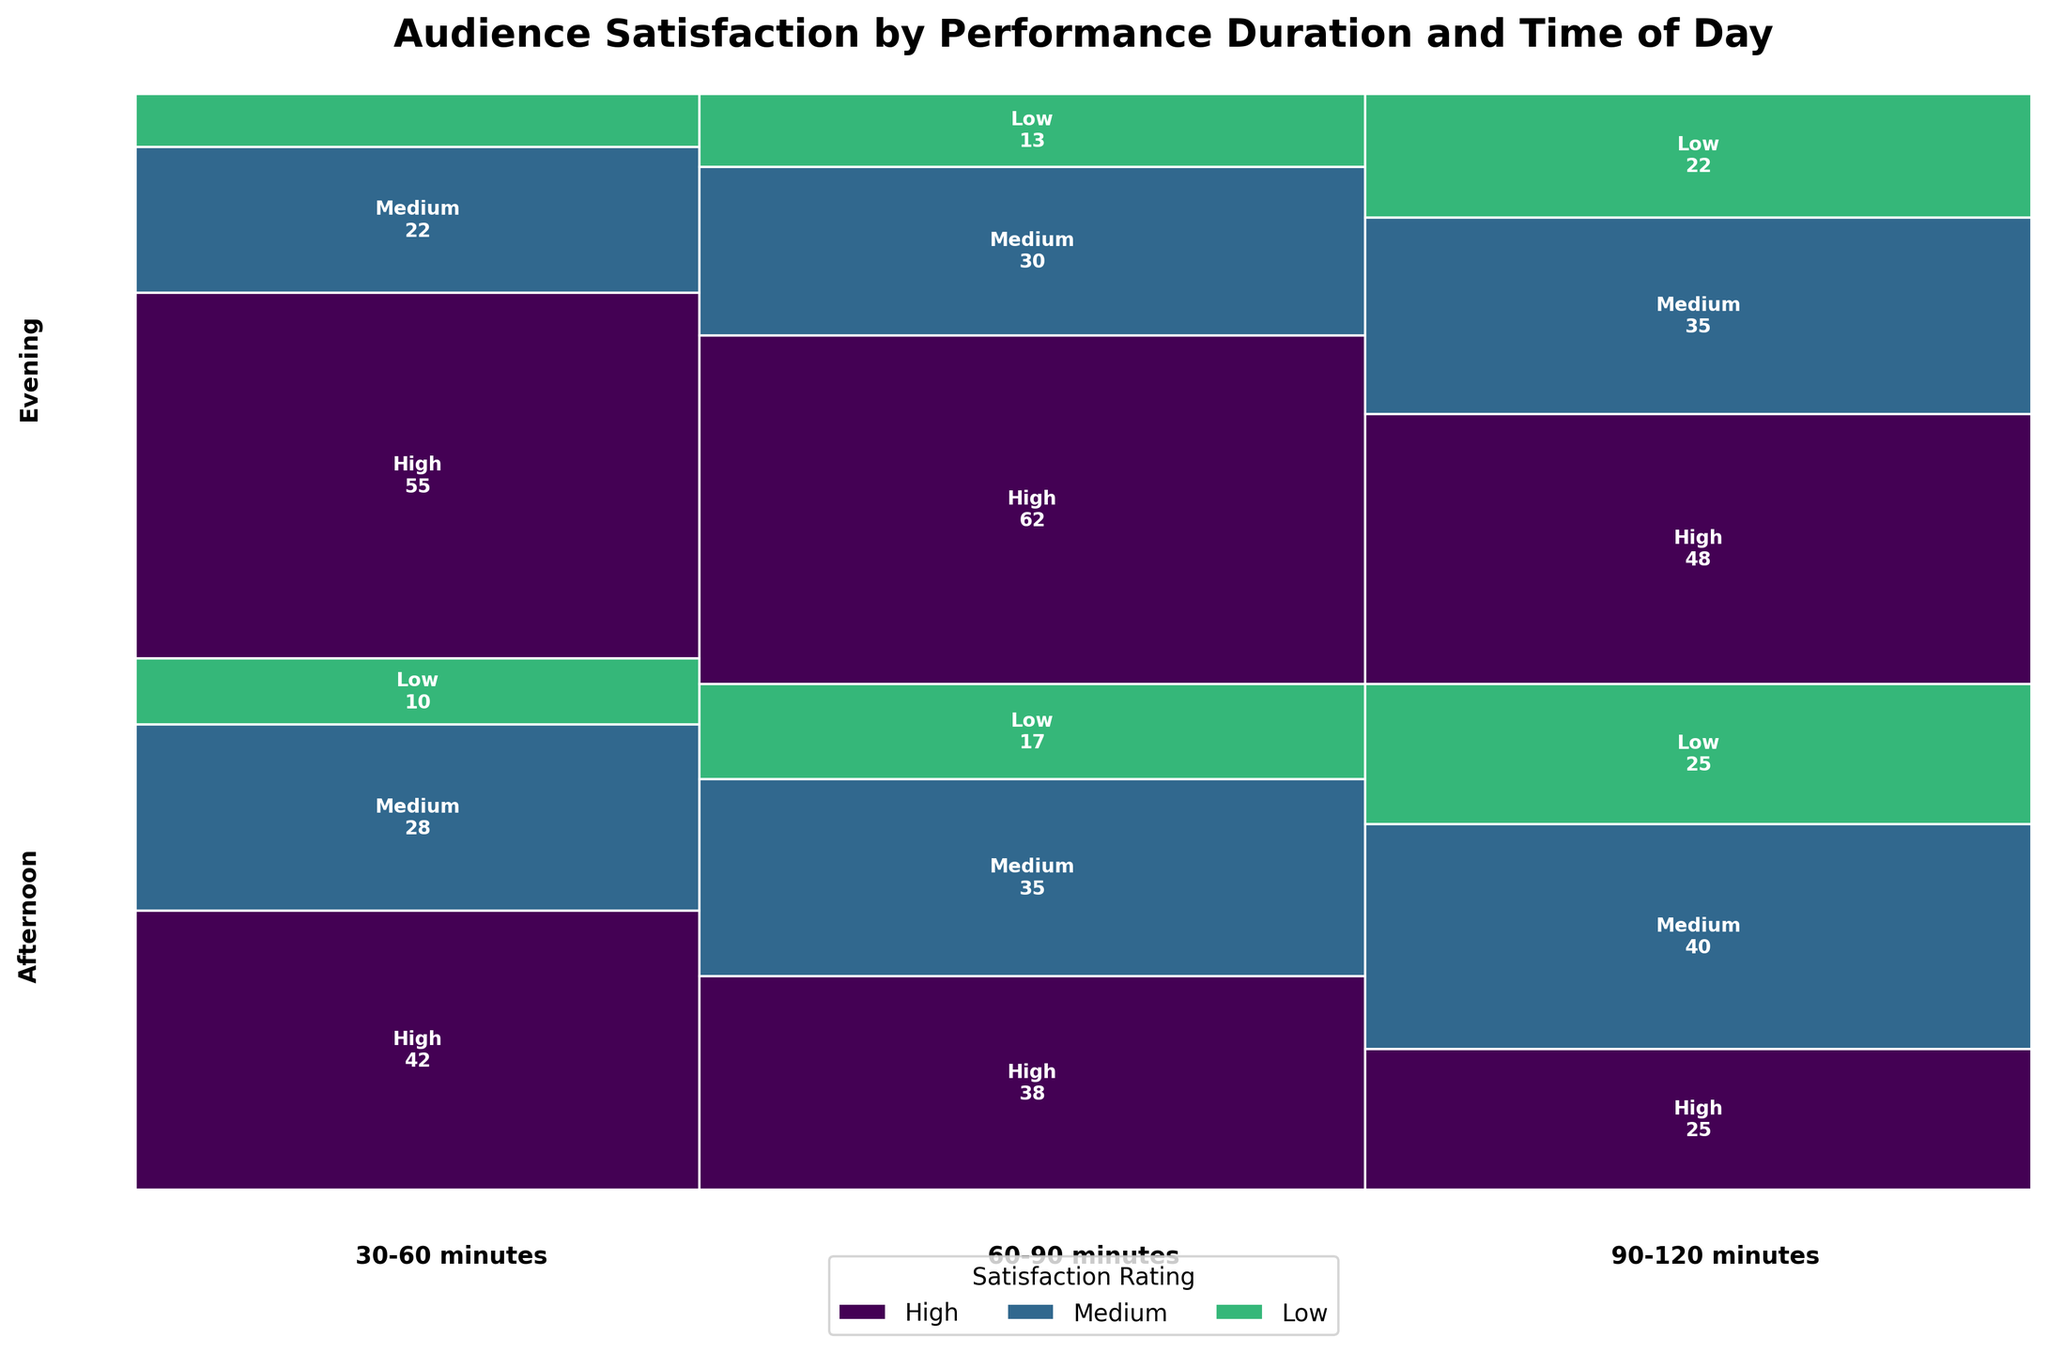what is the most common satisfaction rating for performances lasting 30-60 minutes? The segment of the plot for 30-60 minutes is divided into three satisfaction rating categories: high, medium, and low. By visual inspection, the "high" rating segment is the largest for both afternoon and evening times.
Answer: High how do evening performances of 60-90 minutes compare in terms of high satisfaction ratings to afternoon performances of the same duration? Looking at the portion of the plot corresponding to 60-90 minutes, evening performances have a larger "high" satisfaction segment compared to the afternoon, indicating more high satisfaction ratings in the evening.
Answer: Evening performances have higher satisfaction ratings what is the total count of medium satisfaction ratings for 90-120 minutes performances? The count for medium satisfaction ratings in the afternoon is 40, and in the evening, it is 35. Adding these, 40 + 35 = 75.
Answer: 75 which time of day has higher satisfaction for 60-90 minute performances? By comparing the "high" satisfaction segments for 60-90 minute performances, the evening segment is larger than the afternoon segment.
Answer: Evening what trend can be observed in audience satisfaction ratings as performance duration increases in the afternoon? For the afternoon, as performance duration increases, high satisfaction ratings appear to decrease, while medium and low satisfaction ratings increase. This is evident by inspecting the decreasing size of the "high" segments and increasing sizes of "medium" and "low" segments.
Answer: Satisfaction decreases are high satisfaction ratings more common in shorter or longer performances? High satisfaction ratings are more visually prevalent in shorter performances (30-60 mins and 60-90 mins) compared to longer performances (90-120 mins) by inspecting the sizes of the "high" satisfaction segments.
Answer: Shorter performances what is the ratio of high to medium satisfaction ratings for afternoon performances of 90-120 minutes? There are 25 high satisfaction ratings and 40 medium satisfaction ratings for afternoon performances of 90-120 minutes. The ratio is calculated as 25 / 40, which simplifies to 5:8.
Answer: 5:8 is there any time of day that consistently receives the lowest satisfaction ratings for all performance durations? By inspecting the "low" satisfaction segments, the evening segments for each performance duration (30-60 mins, 60-90 mins, 90-120 mins) are consistently smaller than afternoon segments, indicating fewer low satisfaction ratings.
Answer: No 